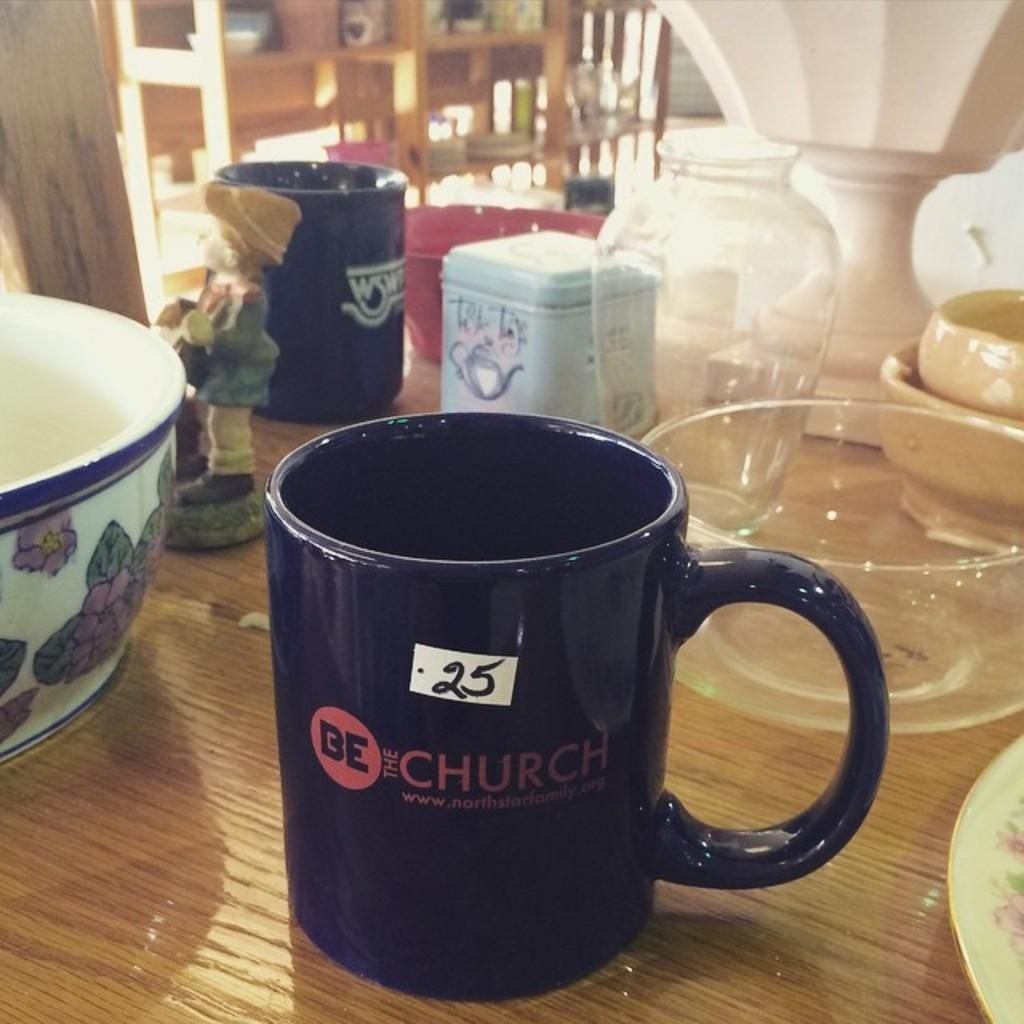<image>
Present a compact description of the photo's key features. wooden table with a be the church mug on it and several bowls 